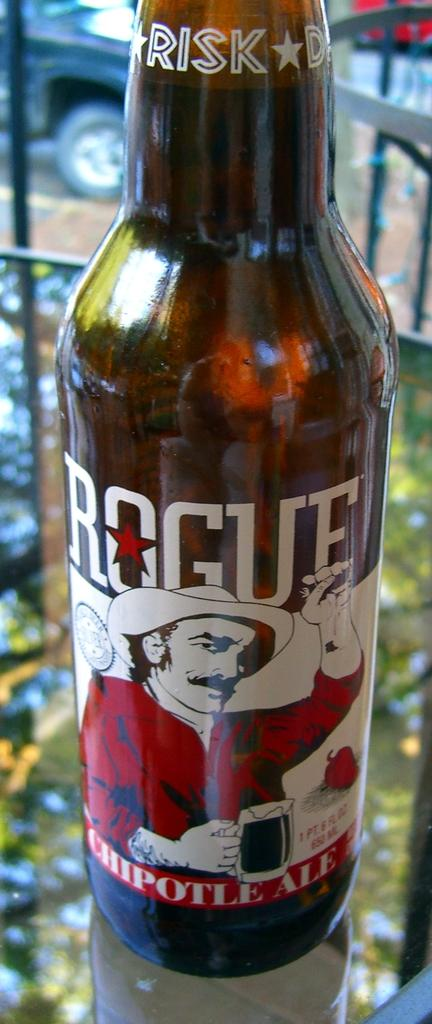What is in the bottle that is visible in the image? There is a bottle of cool drink in the image. What is written on the bottle? The word "RISK" is written at the top of the bottle. What is the man in the image wearing? The man is wearing a red shirt and a hat. What is the hat doing in the image? The hat is on the bottle. How does the man show respect to the boundary in the image? There is no mention of a boundary in the image, so it is not possible to determine how the man shows respect to it. 